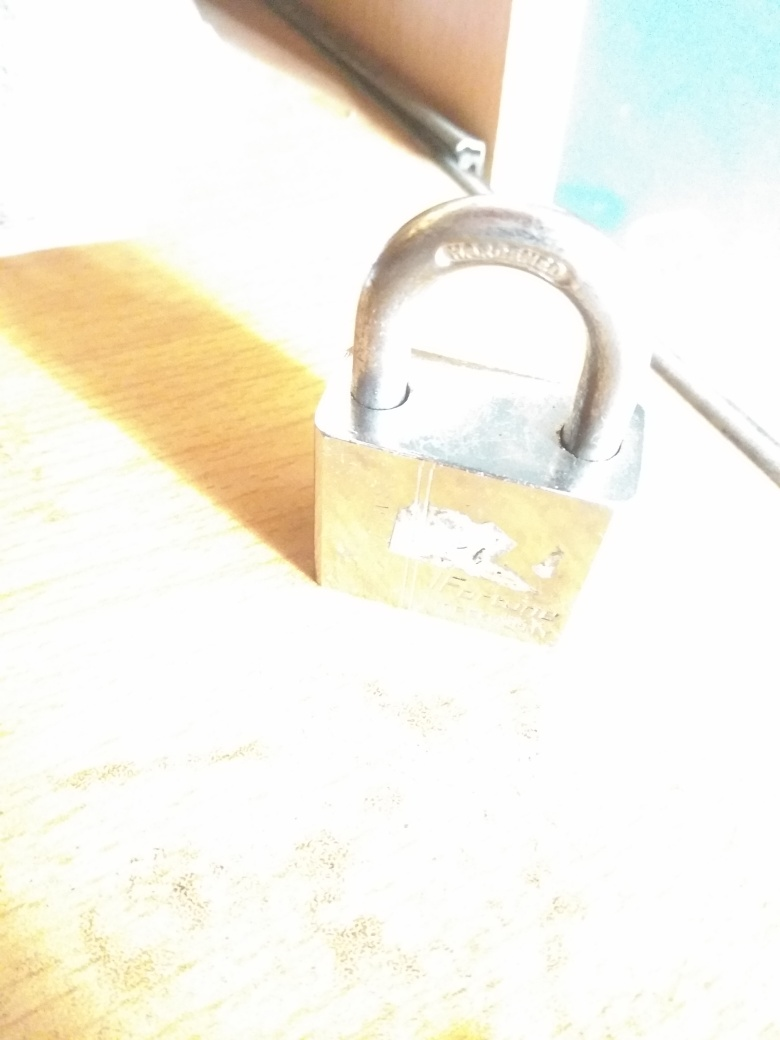Could you describe the type of lighting and its effect on the image? The image is overexposed due to an intense source of light that shines directly on the subject, causing a loss of detail and contrast in the areas affected. This results in the subject appearing overly bright, with some details washed out. 